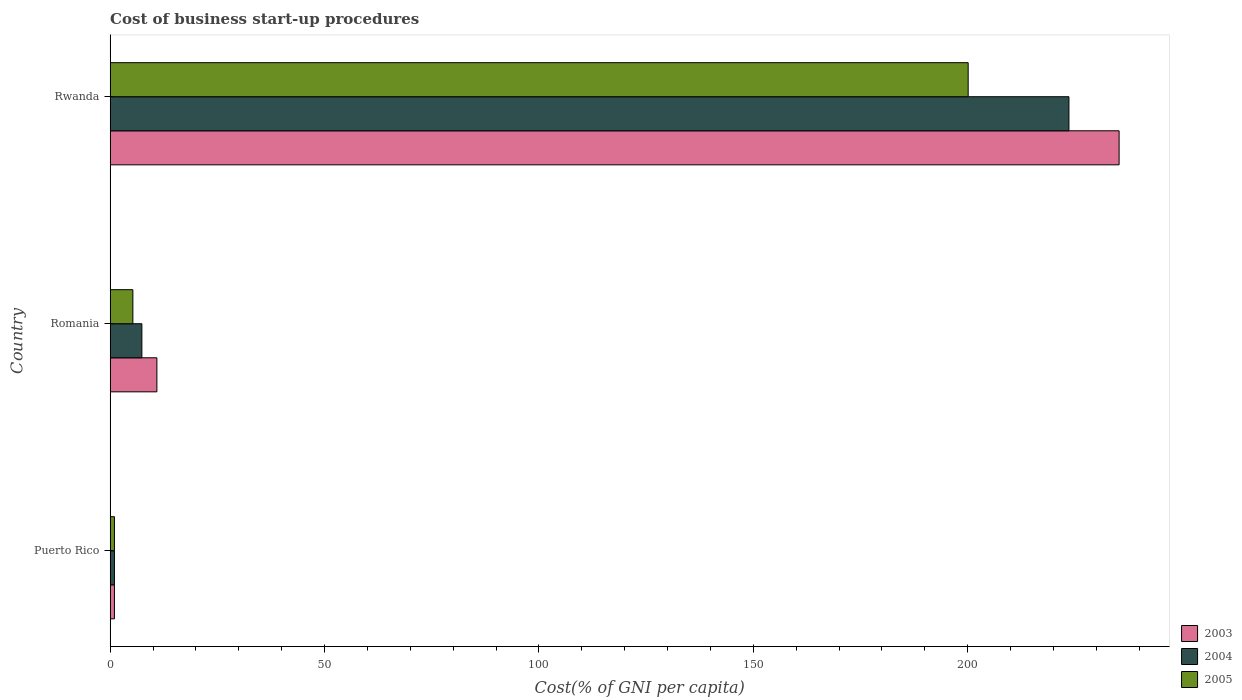How many groups of bars are there?
Give a very brief answer. 3. Are the number of bars per tick equal to the number of legend labels?
Your answer should be very brief. Yes. What is the label of the 1st group of bars from the top?
Ensure brevity in your answer.  Rwanda. In how many cases, is the number of bars for a given country not equal to the number of legend labels?
Give a very brief answer. 0. What is the cost of business start-up procedures in 2004 in Puerto Rico?
Ensure brevity in your answer.  1. Across all countries, what is the maximum cost of business start-up procedures in 2003?
Give a very brief answer. 235.3. Across all countries, what is the minimum cost of business start-up procedures in 2004?
Keep it short and to the point. 1. In which country was the cost of business start-up procedures in 2003 maximum?
Give a very brief answer. Rwanda. In which country was the cost of business start-up procedures in 2003 minimum?
Keep it short and to the point. Puerto Rico. What is the total cost of business start-up procedures in 2005 in the graph?
Offer a terse response. 206.4. What is the difference between the cost of business start-up procedures in 2004 in Romania and that in Rwanda?
Keep it short and to the point. -216.2. What is the average cost of business start-up procedures in 2004 per country?
Your answer should be very brief. 77.33. What is the difference between the cost of business start-up procedures in 2003 and cost of business start-up procedures in 2005 in Puerto Rico?
Ensure brevity in your answer.  0. What is the ratio of the cost of business start-up procedures in 2003 in Puerto Rico to that in Romania?
Your response must be concise. 0.09. Is the cost of business start-up procedures in 2003 in Puerto Rico less than that in Romania?
Provide a succinct answer. Yes. What is the difference between the highest and the second highest cost of business start-up procedures in 2005?
Offer a very short reply. 194.8. What is the difference between the highest and the lowest cost of business start-up procedures in 2003?
Ensure brevity in your answer.  234.3. Is the sum of the cost of business start-up procedures in 2004 in Puerto Rico and Romania greater than the maximum cost of business start-up procedures in 2005 across all countries?
Make the answer very short. No. What does the 2nd bar from the top in Rwanda represents?
Provide a short and direct response. 2004. Is it the case that in every country, the sum of the cost of business start-up procedures in 2004 and cost of business start-up procedures in 2005 is greater than the cost of business start-up procedures in 2003?
Your answer should be very brief. Yes. Are all the bars in the graph horizontal?
Your answer should be very brief. Yes. Does the graph contain grids?
Ensure brevity in your answer.  No. What is the title of the graph?
Give a very brief answer. Cost of business start-up procedures. What is the label or title of the X-axis?
Your response must be concise. Cost(% of GNI per capita). What is the Cost(% of GNI per capita) of 2005 in Puerto Rico?
Offer a very short reply. 1. What is the Cost(% of GNI per capita) of 2003 in Romania?
Your answer should be very brief. 10.9. What is the Cost(% of GNI per capita) of 2003 in Rwanda?
Provide a succinct answer. 235.3. What is the Cost(% of GNI per capita) of 2004 in Rwanda?
Your response must be concise. 223.6. What is the Cost(% of GNI per capita) in 2005 in Rwanda?
Provide a succinct answer. 200.1. Across all countries, what is the maximum Cost(% of GNI per capita) of 2003?
Make the answer very short. 235.3. Across all countries, what is the maximum Cost(% of GNI per capita) of 2004?
Make the answer very short. 223.6. Across all countries, what is the maximum Cost(% of GNI per capita) in 2005?
Give a very brief answer. 200.1. Across all countries, what is the minimum Cost(% of GNI per capita) in 2005?
Give a very brief answer. 1. What is the total Cost(% of GNI per capita) in 2003 in the graph?
Your answer should be compact. 247.2. What is the total Cost(% of GNI per capita) in 2004 in the graph?
Provide a short and direct response. 232. What is the total Cost(% of GNI per capita) of 2005 in the graph?
Keep it short and to the point. 206.4. What is the difference between the Cost(% of GNI per capita) of 2003 in Puerto Rico and that in Romania?
Ensure brevity in your answer.  -9.9. What is the difference between the Cost(% of GNI per capita) in 2004 in Puerto Rico and that in Romania?
Your response must be concise. -6.4. What is the difference between the Cost(% of GNI per capita) in 2005 in Puerto Rico and that in Romania?
Your response must be concise. -4.3. What is the difference between the Cost(% of GNI per capita) in 2003 in Puerto Rico and that in Rwanda?
Give a very brief answer. -234.3. What is the difference between the Cost(% of GNI per capita) of 2004 in Puerto Rico and that in Rwanda?
Give a very brief answer. -222.6. What is the difference between the Cost(% of GNI per capita) in 2005 in Puerto Rico and that in Rwanda?
Your answer should be very brief. -199.1. What is the difference between the Cost(% of GNI per capita) in 2003 in Romania and that in Rwanda?
Give a very brief answer. -224.4. What is the difference between the Cost(% of GNI per capita) of 2004 in Romania and that in Rwanda?
Provide a short and direct response. -216.2. What is the difference between the Cost(% of GNI per capita) in 2005 in Romania and that in Rwanda?
Your response must be concise. -194.8. What is the difference between the Cost(% of GNI per capita) of 2003 in Puerto Rico and the Cost(% of GNI per capita) of 2005 in Romania?
Give a very brief answer. -4.3. What is the difference between the Cost(% of GNI per capita) in 2004 in Puerto Rico and the Cost(% of GNI per capita) in 2005 in Romania?
Give a very brief answer. -4.3. What is the difference between the Cost(% of GNI per capita) in 2003 in Puerto Rico and the Cost(% of GNI per capita) in 2004 in Rwanda?
Provide a short and direct response. -222.6. What is the difference between the Cost(% of GNI per capita) of 2003 in Puerto Rico and the Cost(% of GNI per capita) of 2005 in Rwanda?
Your answer should be compact. -199.1. What is the difference between the Cost(% of GNI per capita) of 2004 in Puerto Rico and the Cost(% of GNI per capita) of 2005 in Rwanda?
Keep it short and to the point. -199.1. What is the difference between the Cost(% of GNI per capita) in 2003 in Romania and the Cost(% of GNI per capita) in 2004 in Rwanda?
Offer a very short reply. -212.7. What is the difference between the Cost(% of GNI per capita) of 2003 in Romania and the Cost(% of GNI per capita) of 2005 in Rwanda?
Offer a very short reply. -189.2. What is the difference between the Cost(% of GNI per capita) of 2004 in Romania and the Cost(% of GNI per capita) of 2005 in Rwanda?
Keep it short and to the point. -192.7. What is the average Cost(% of GNI per capita) in 2003 per country?
Make the answer very short. 82.4. What is the average Cost(% of GNI per capita) in 2004 per country?
Make the answer very short. 77.33. What is the average Cost(% of GNI per capita) of 2005 per country?
Offer a very short reply. 68.8. What is the difference between the Cost(% of GNI per capita) in 2003 and Cost(% of GNI per capita) in 2004 in Puerto Rico?
Provide a short and direct response. 0. What is the difference between the Cost(% of GNI per capita) in 2003 and Cost(% of GNI per capita) in 2005 in Puerto Rico?
Make the answer very short. 0. What is the difference between the Cost(% of GNI per capita) in 2003 and Cost(% of GNI per capita) in 2004 in Romania?
Ensure brevity in your answer.  3.5. What is the difference between the Cost(% of GNI per capita) in 2004 and Cost(% of GNI per capita) in 2005 in Romania?
Your response must be concise. 2.1. What is the difference between the Cost(% of GNI per capita) in 2003 and Cost(% of GNI per capita) in 2005 in Rwanda?
Provide a short and direct response. 35.2. What is the difference between the Cost(% of GNI per capita) in 2004 and Cost(% of GNI per capita) in 2005 in Rwanda?
Provide a succinct answer. 23.5. What is the ratio of the Cost(% of GNI per capita) in 2003 in Puerto Rico to that in Romania?
Your answer should be very brief. 0.09. What is the ratio of the Cost(% of GNI per capita) of 2004 in Puerto Rico to that in Romania?
Keep it short and to the point. 0.14. What is the ratio of the Cost(% of GNI per capita) in 2005 in Puerto Rico to that in Romania?
Your answer should be very brief. 0.19. What is the ratio of the Cost(% of GNI per capita) in 2003 in Puerto Rico to that in Rwanda?
Ensure brevity in your answer.  0. What is the ratio of the Cost(% of GNI per capita) of 2004 in Puerto Rico to that in Rwanda?
Your answer should be very brief. 0. What is the ratio of the Cost(% of GNI per capita) of 2005 in Puerto Rico to that in Rwanda?
Your answer should be compact. 0.01. What is the ratio of the Cost(% of GNI per capita) in 2003 in Romania to that in Rwanda?
Keep it short and to the point. 0.05. What is the ratio of the Cost(% of GNI per capita) in 2004 in Romania to that in Rwanda?
Provide a succinct answer. 0.03. What is the ratio of the Cost(% of GNI per capita) of 2005 in Romania to that in Rwanda?
Make the answer very short. 0.03. What is the difference between the highest and the second highest Cost(% of GNI per capita) in 2003?
Provide a short and direct response. 224.4. What is the difference between the highest and the second highest Cost(% of GNI per capita) in 2004?
Give a very brief answer. 216.2. What is the difference between the highest and the second highest Cost(% of GNI per capita) in 2005?
Your answer should be very brief. 194.8. What is the difference between the highest and the lowest Cost(% of GNI per capita) of 2003?
Your answer should be very brief. 234.3. What is the difference between the highest and the lowest Cost(% of GNI per capita) in 2004?
Make the answer very short. 222.6. What is the difference between the highest and the lowest Cost(% of GNI per capita) in 2005?
Your answer should be compact. 199.1. 